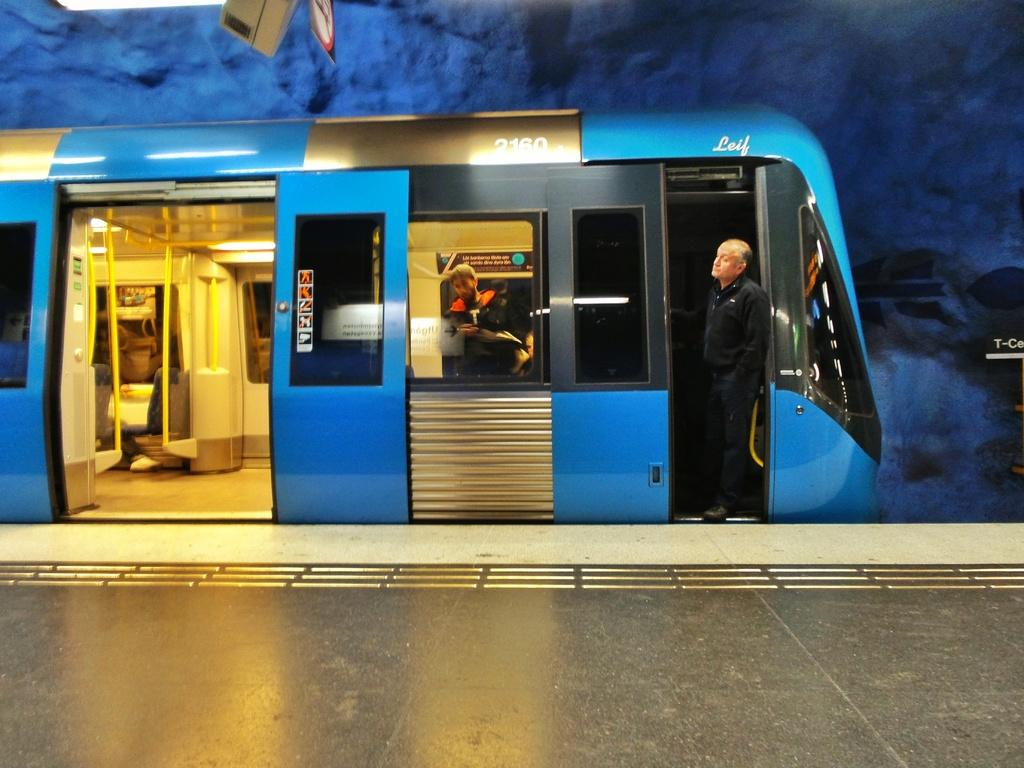What mode of transportation are the people in the image using? The people are in a train. What material are the rods in the image made of? The rods in the image are made of metal. What can be used for illumination in the image? There are lights in the image. Can you see a toad hopping on the train in the image? There is no toad present in the image. What suggestion is being made by the people in the image? The image does not provide any information about suggestions being made by the people. 